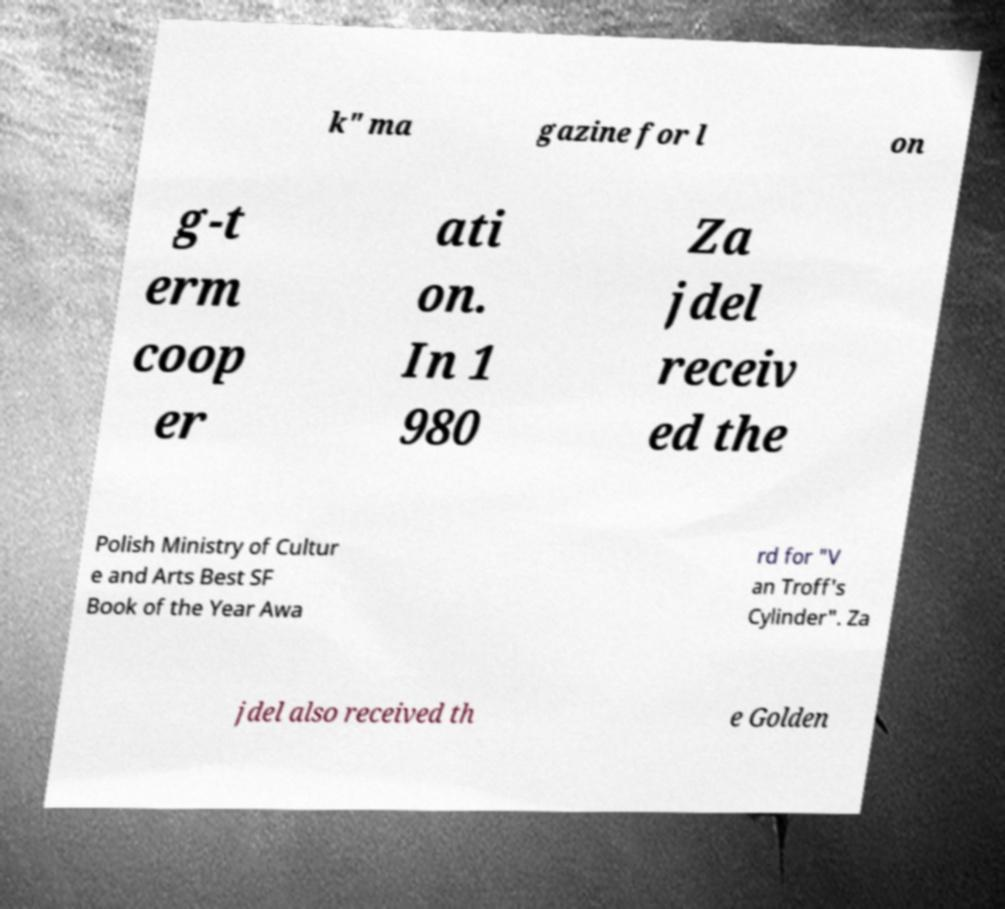There's text embedded in this image that I need extracted. Can you transcribe it verbatim? k" ma gazine for l on g-t erm coop er ati on. In 1 980 Za jdel receiv ed the Polish Ministry of Cultur e and Arts Best SF Book of the Year Awa rd for "V an Troff's Cylinder". Za jdel also received th e Golden 